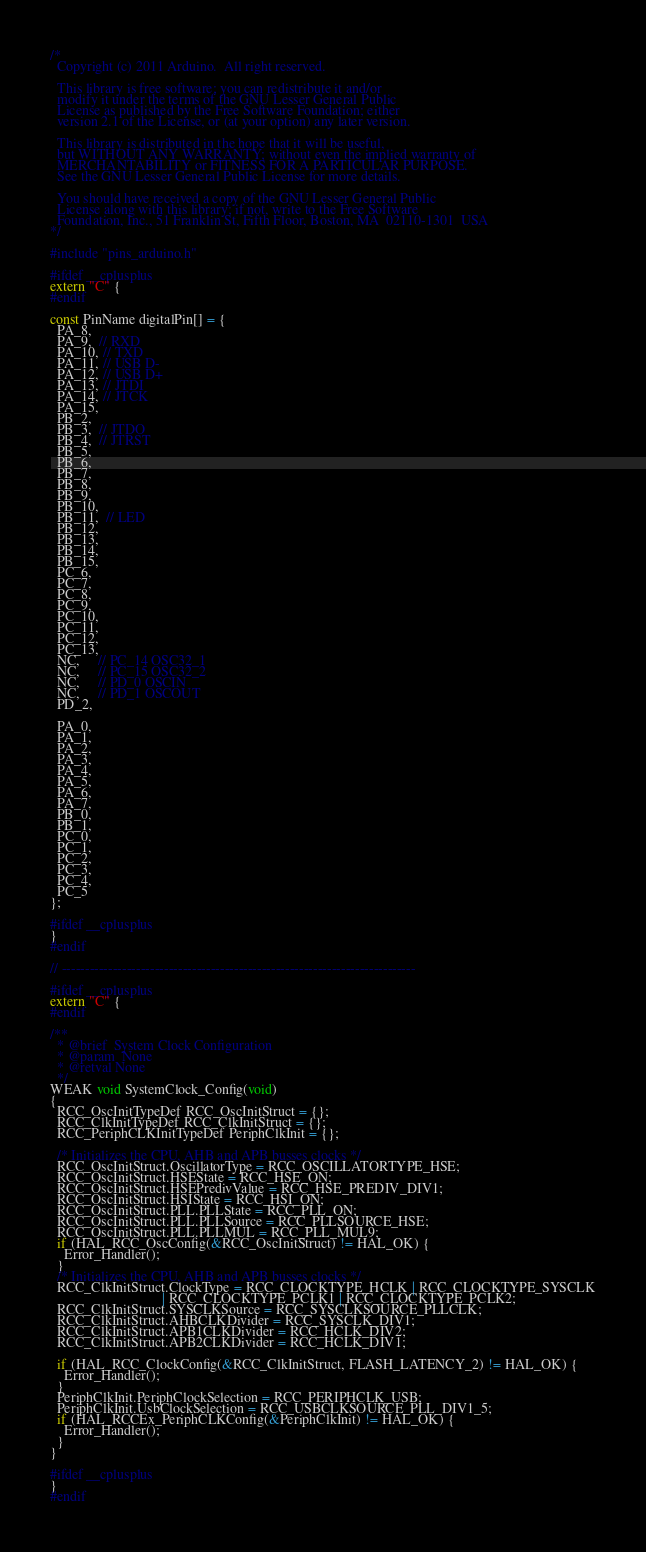<code> <loc_0><loc_0><loc_500><loc_500><_C++_>/*
  Copyright (c) 2011 Arduino.  All right reserved.

  This library is free software; you can redistribute it and/or
  modify it under the terms of the GNU Lesser General Public
  License as published by the Free Software Foundation; either
  version 2.1 of the License, or (at your option) any later version.

  This library is distributed in the hope that it will be useful,
  but WITHOUT ANY WARRANTY; without even the implied warranty of
  MERCHANTABILITY or FITNESS FOR A PARTICULAR PURPOSE.
  See the GNU Lesser General Public License for more details.

  You should have received a copy of the GNU Lesser General Public
  License along with this library; if not, write to the Free Software
  Foundation, Inc., 51 Franklin St, Fifth Floor, Boston, MA  02110-1301  USA
*/

#include "pins_arduino.h"

#ifdef __cplusplus
extern "C" {
#endif

const PinName digitalPin[] = {
  PA_8,
  PA_9,  // RXD
  PA_10, // TXD
  PA_11, // USB D-
  PA_12, // USB D+
  PA_13, // JTDI
  PA_14, // JTCK
  PA_15,
  PB_2,
  PB_3,  // JTDO
  PB_4,  // JTRST
  PB_5,
  PB_6,
  PB_7,
  PB_8,
  PB_9,
  PB_10,
  PB_11,  // LED
  PB_12,
  PB_13,
  PB_14,
  PB_15,
  PC_6,
  PC_7,
  PC_8,
  PC_9,
  PC_10,
  PC_11,
  PC_12,
  PC_13,
  NC,     // PC_14 OSC32_1
  NC,     // PC_15 OSC32_2
  NC,     // PD_0 OSCIN
  NC,     // PD_1 OSCOUT
  PD_2,

  PA_0,
  PA_1,
  PA_2,
  PA_3,
  PA_4,
  PA_5,
  PA_6,
  PA_7,
  PB_0,
  PB_1,
  PC_0,
  PC_1,
  PC_2,
  PC_3,
  PC_4,
  PC_5
};

#ifdef __cplusplus
}
#endif

// ----------------------------------------------------------------------------

#ifdef __cplusplus
extern "C" {
#endif

/**
  * @brief  System Clock Configuration
  * @param  None
  * @retval None
  */
WEAK void SystemClock_Config(void)
{
  RCC_OscInitTypeDef RCC_OscInitStruct = {};
  RCC_ClkInitTypeDef RCC_ClkInitStruct = {};
  RCC_PeriphCLKInitTypeDef PeriphClkInit = {};

  /* Initializes the CPU, AHB and APB busses clocks */
  RCC_OscInitStruct.OscillatorType = RCC_OSCILLATORTYPE_HSE;
  RCC_OscInitStruct.HSEState = RCC_HSE_ON;
  RCC_OscInitStruct.HSEPredivValue = RCC_HSE_PREDIV_DIV1;
  RCC_OscInitStruct.HSIState = RCC_HSI_ON;
  RCC_OscInitStruct.PLL.PLLState = RCC_PLL_ON;
  RCC_OscInitStruct.PLL.PLLSource = RCC_PLLSOURCE_HSE;
  RCC_OscInitStruct.PLL.PLLMUL = RCC_PLL_MUL9;
  if (HAL_RCC_OscConfig(&RCC_OscInitStruct) != HAL_OK) {
    Error_Handler();
  }
  /* Initializes the CPU, AHB and APB busses clocks */
  RCC_ClkInitStruct.ClockType = RCC_CLOCKTYPE_HCLK | RCC_CLOCKTYPE_SYSCLK
                                | RCC_CLOCKTYPE_PCLK1 | RCC_CLOCKTYPE_PCLK2;
  RCC_ClkInitStruct.SYSCLKSource = RCC_SYSCLKSOURCE_PLLCLK;
  RCC_ClkInitStruct.AHBCLKDivider = RCC_SYSCLK_DIV1;
  RCC_ClkInitStruct.APB1CLKDivider = RCC_HCLK_DIV2;
  RCC_ClkInitStruct.APB2CLKDivider = RCC_HCLK_DIV1;

  if (HAL_RCC_ClockConfig(&RCC_ClkInitStruct, FLASH_LATENCY_2) != HAL_OK) {
    Error_Handler();
  }
  PeriphClkInit.PeriphClockSelection = RCC_PERIPHCLK_USB;
  PeriphClkInit.UsbClockSelection = RCC_USBCLKSOURCE_PLL_DIV1_5;
  if (HAL_RCCEx_PeriphCLKConfig(&PeriphClkInit) != HAL_OK) {
    Error_Handler();
  }
}

#ifdef __cplusplus
}
#endif
</code> 